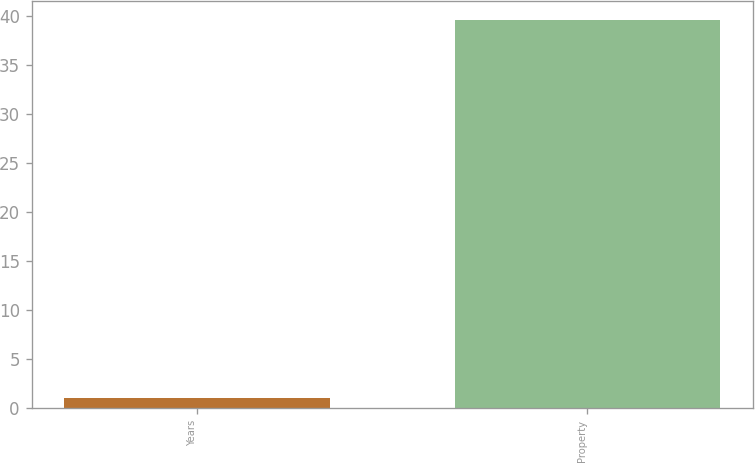Convert chart. <chart><loc_0><loc_0><loc_500><loc_500><bar_chart><fcel>Years<fcel>Property<nl><fcel>1<fcel>39.6<nl></chart> 